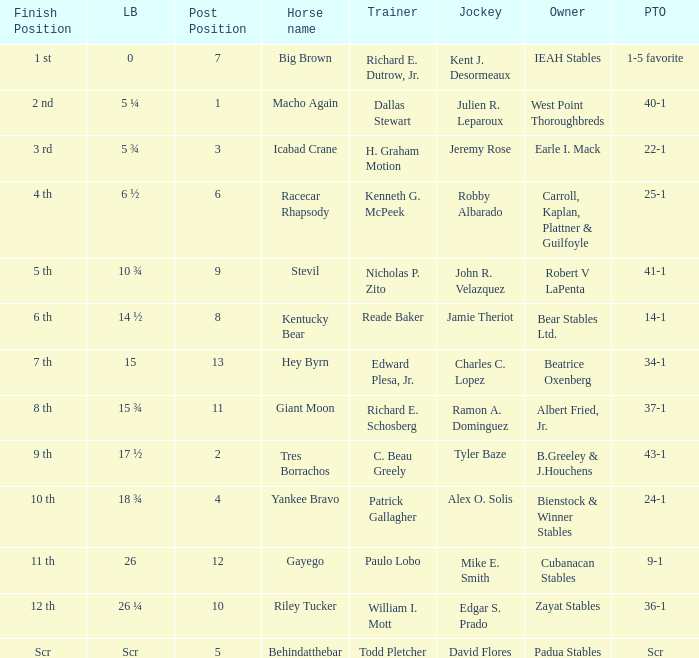What's the lengths behind of Jockey Ramon A. Dominguez? 15 ¾. 